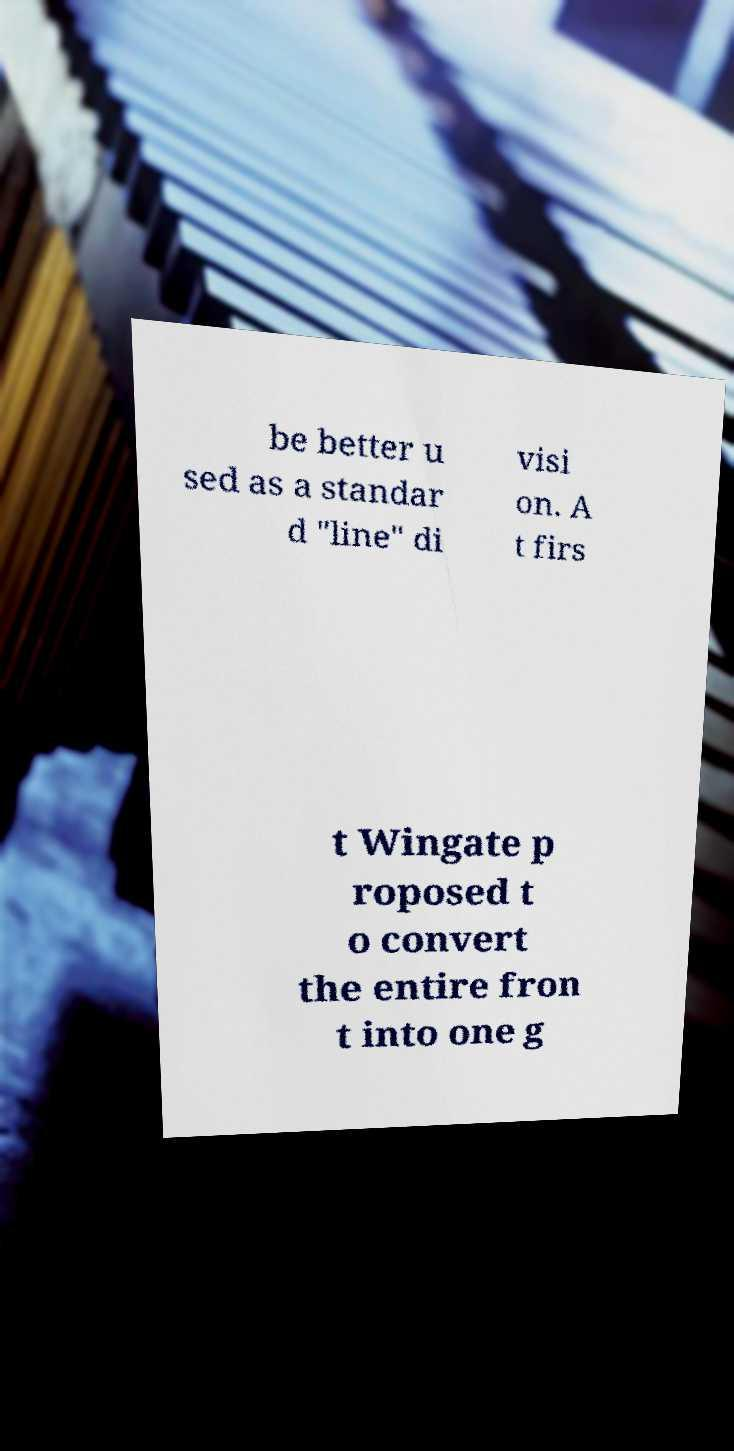There's text embedded in this image that I need extracted. Can you transcribe it verbatim? be better u sed as a standar d "line" di visi on. A t firs t Wingate p roposed t o convert the entire fron t into one g 